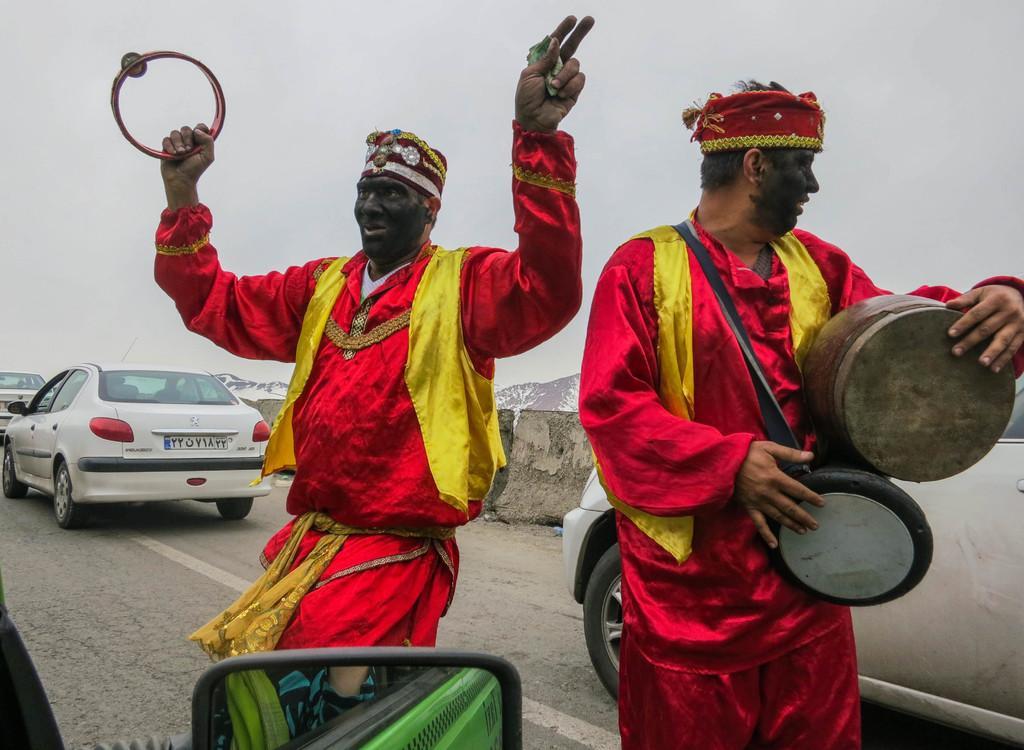Could you give a brief overview of what you see in this image? This Image is clicked outside. In this image there are three cars and two men. Two men are in the middle they are wearing some cow costume which is in red and yellow color. One of them is holding drums. They also have caps. These cars have number plates tail light and tires. All of them are in white color. On the top there is Sky. 